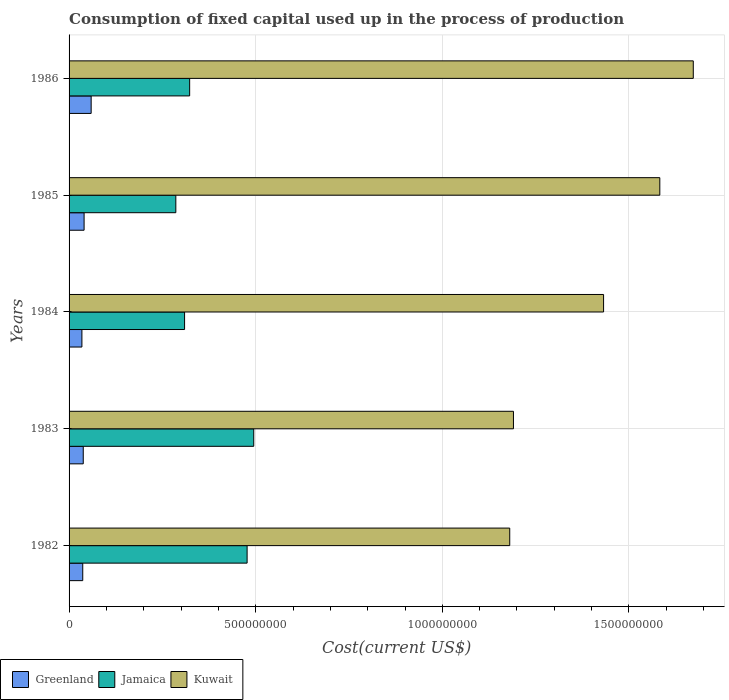Are the number of bars on each tick of the Y-axis equal?
Give a very brief answer. Yes. How many bars are there on the 3rd tick from the top?
Your response must be concise. 3. How many bars are there on the 1st tick from the bottom?
Ensure brevity in your answer.  3. What is the amount consumed in the process of production in Greenland in 1985?
Your response must be concise. 4.02e+07. Across all years, what is the maximum amount consumed in the process of production in Kuwait?
Offer a terse response. 1.67e+09. Across all years, what is the minimum amount consumed in the process of production in Jamaica?
Ensure brevity in your answer.  2.86e+08. In which year was the amount consumed in the process of production in Jamaica maximum?
Your answer should be compact. 1983. In which year was the amount consumed in the process of production in Jamaica minimum?
Keep it short and to the point. 1985. What is the total amount consumed in the process of production in Jamaica in the graph?
Your answer should be very brief. 1.89e+09. What is the difference between the amount consumed in the process of production in Kuwait in 1982 and that in 1985?
Ensure brevity in your answer.  -4.02e+08. What is the difference between the amount consumed in the process of production in Kuwait in 1983 and the amount consumed in the process of production in Jamaica in 1984?
Your response must be concise. 8.81e+08. What is the average amount consumed in the process of production in Greenland per year?
Make the answer very short. 4.17e+07. In the year 1983, what is the difference between the amount consumed in the process of production in Jamaica and amount consumed in the process of production in Greenland?
Give a very brief answer. 4.57e+08. What is the ratio of the amount consumed in the process of production in Greenland in 1984 to that in 1986?
Provide a short and direct response. 0.58. Is the amount consumed in the process of production in Jamaica in 1983 less than that in 1984?
Make the answer very short. No. Is the difference between the amount consumed in the process of production in Jamaica in 1985 and 1986 greater than the difference between the amount consumed in the process of production in Greenland in 1985 and 1986?
Give a very brief answer. No. What is the difference between the highest and the second highest amount consumed in the process of production in Kuwait?
Make the answer very short. 8.97e+07. What is the difference between the highest and the lowest amount consumed in the process of production in Jamaica?
Your answer should be compact. 2.09e+08. In how many years, is the amount consumed in the process of production in Greenland greater than the average amount consumed in the process of production in Greenland taken over all years?
Your answer should be compact. 1. What does the 3rd bar from the top in 1983 represents?
Provide a short and direct response. Greenland. What does the 1st bar from the bottom in 1986 represents?
Offer a very short reply. Greenland. What is the difference between two consecutive major ticks on the X-axis?
Your answer should be compact. 5.00e+08. Are the values on the major ticks of X-axis written in scientific E-notation?
Ensure brevity in your answer.  No. Where does the legend appear in the graph?
Offer a terse response. Bottom left. What is the title of the graph?
Your response must be concise. Consumption of fixed capital used up in the process of production. What is the label or title of the X-axis?
Make the answer very short. Cost(current US$). What is the Cost(current US$) of Greenland in 1982?
Make the answer very short. 3.66e+07. What is the Cost(current US$) in Jamaica in 1982?
Give a very brief answer. 4.77e+08. What is the Cost(current US$) of Kuwait in 1982?
Provide a short and direct response. 1.18e+09. What is the Cost(current US$) of Greenland in 1983?
Offer a very short reply. 3.80e+07. What is the Cost(current US$) in Jamaica in 1983?
Your answer should be compact. 4.95e+08. What is the Cost(current US$) of Kuwait in 1983?
Offer a very short reply. 1.19e+09. What is the Cost(current US$) in Greenland in 1984?
Provide a succinct answer. 3.44e+07. What is the Cost(current US$) in Jamaica in 1984?
Ensure brevity in your answer.  3.09e+08. What is the Cost(current US$) in Kuwait in 1984?
Keep it short and to the point. 1.43e+09. What is the Cost(current US$) in Greenland in 1985?
Provide a succinct answer. 4.02e+07. What is the Cost(current US$) of Jamaica in 1985?
Ensure brevity in your answer.  2.86e+08. What is the Cost(current US$) in Kuwait in 1985?
Provide a succinct answer. 1.58e+09. What is the Cost(current US$) of Greenland in 1986?
Make the answer very short. 5.92e+07. What is the Cost(current US$) in Jamaica in 1986?
Your answer should be very brief. 3.23e+08. What is the Cost(current US$) in Kuwait in 1986?
Keep it short and to the point. 1.67e+09. Across all years, what is the maximum Cost(current US$) in Greenland?
Offer a very short reply. 5.92e+07. Across all years, what is the maximum Cost(current US$) of Jamaica?
Provide a succinct answer. 4.95e+08. Across all years, what is the maximum Cost(current US$) in Kuwait?
Give a very brief answer. 1.67e+09. Across all years, what is the minimum Cost(current US$) of Greenland?
Make the answer very short. 3.44e+07. Across all years, what is the minimum Cost(current US$) of Jamaica?
Your answer should be compact. 2.86e+08. Across all years, what is the minimum Cost(current US$) of Kuwait?
Your response must be concise. 1.18e+09. What is the total Cost(current US$) in Greenland in the graph?
Your answer should be very brief. 2.08e+08. What is the total Cost(current US$) in Jamaica in the graph?
Your response must be concise. 1.89e+09. What is the total Cost(current US$) in Kuwait in the graph?
Your answer should be very brief. 7.06e+09. What is the difference between the Cost(current US$) in Greenland in 1982 and that in 1983?
Provide a short and direct response. -1.35e+06. What is the difference between the Cost(current US$) of Jamaica in 1982 and that in 1983?
Give a very brief answer. -1.78e+07. What is the difference between the Cost(current US$) in Kuwait in 1982 and that in 1983?
Your response must be concise. -9.98e+06. What is the difference between the Cost(current US$) of Greenland in 1982 and that in 1984?
Give a very brief answer. 2.26e+06. What is the difference between the Cost(current US$) in Jamaica in 1982 and that in 1984?
Your response must be concise. 1.68e+08. What is the difference between the Cost(current US$) of Kuwait in 1982 and that in 1984?
Give a very brief answer. -2.51e+08. What is the difference between the Cost(current US$) in Greenland in 1982 and that in 1985?
Make the answer very short. -3.58e+06. What is the difference between the Cost(current US$) in Jamaica in 1982 and that in 1985?
Offer a very short reply. 1.91e+08. What is the difference between the Cost(current US$) of Kuwait in 1982 and that in 1985?
Provide a short and direct response. -4.02e+08. What is the difference between the Cost(current US$) of Greenland in 1982 and that in 1986?
Provide a short and direct response. -2.25e+07. What is the difference between the Cost(current US$) of Jamaica in 1982 and that in 1986?
Give a very brief answer. 1.54e+08. What is the difference between the Cost(current US$) in Kuwait in 1982 and that in 1986?
Your answer should be very brief. -4.92e+08. What is the difference between the Cost(current US$) of Greenland in 1983 and that in 1984?
Your answer should be compact. 3.62e+06. What is the difference between the Cost(current US$) of Jamaica in 1983 and that in 1984?
Offer a terse response. 1.85e+08. What is the difference between the Cost(current US$) in Kuwait in 1983 and that in 1984?
Your answer should be very brief. -2.41e+08. What is the difference between the Cost(current US$) in Greenland in 1983 and that in 1985?
Offer a terse response. -2.23e+06. What is the difference between the Cost(current US$) of Jamaica in 1983 and that in 1985?
Provide a succinct answer. 2.09e+08. What is the difference between the Cost(current US$) in Kuwait in 1983 and that in 1985?
Offer a terse response. -3.92e+08. What is the difference between the Cost(current US$) in Greenland in 1983 and that in 1986?
Your answer should be very brief. -2.12e+07. What is the difference between the Cost(current US$) of Jamaica in 1983 and that in 1986?
Make the answer very short. 1.72e+08. What is the difference between the Cost(current US$) in Kuwait in 1983 and that in 1986?
Your answer should be very brief. -4.82e+08. What is the difference between the Cost(current US$) of Greenland in 1984 and that in 1985?
Your response must be concise. -5.85e+06. What is the difference between the Cost(current US$) of Jamaica in 1984 and that in 1985?
Give a very brief answer. 2.35e+07. What is the difference between the Cost(current US$) of Kuwait in 1984 and that in 1985?
Keep it short and to the point. -1.51e+08. What is the difference between the Cost(current US$) in Greenland in 1984 and that in 1986?
Your answer should be compact. -2.48e+07. What is the difference between the Cost(current US$) of Jamaica in 1984 and that in 1986?
Provide a succinct answer. -1.36e+07. What is the difference between the Cost(current US$) in Kuwait in 1984 and that in 1986?
Provide a succinct answer. -2.40e+08. What is the difference between the Cost(current US$) in Greenland in 1985 and that in 1986?
Give a very brief answer. -1.89e+07. What is the difference between the Cost(current US$) of Jamaica in 1985 and that in 1986?
Make the answer very short. -3.70e+07. What is the difference between the Cost(current US$) of Kuwait in 1985 and that in 1986?
Ensure brevity in your answer.  -8.97e+07. What is the difference between the Cost(current US$) of Greenland in 1982 and the Cost(current US$) of Jamaica in 1983?
Offer a very short reply. -4.58e+08. What is the difference between the Cost(current US$) of Greenland in 1982 and the Cost(current US$) of Kuwait in 1983?
Offer a very short reply. -1.15e+09. What is the difference between the Cost(current US$) of Jamaica in 1982 and the Cost(current US$) of Kuwait in 1983?
Your response must be concise. -7.14e+08. What is the difference between the Cost(current US$) of Greenland in 1982 and the Cost(current US$) of Jamaica in 1984?
Offer a terse response. -2.73e+08. What is the difference between the Cost(current US$) in Greenland in 1982 and the Cost(current US$) in Kuwait in 1984?
Provide a short and direct response. -1.40e+09. What is the difference between the Cost(current US$) in Jamaica in 1982 and the Cost(current US$) in Kuwait in 1984?
Your response must be concise. -9.55e+08. What is the difference between the Cost(current US$) in Greenland in 1982 and the Cost(current US$) in Jamaica in 1985?
Give a very brief answer. -2.49e+08. What is the difference between the Cost(current US$) in Greenland in 1982 and the Cost(current US$) in Kuwait in 1985?
Your response must be concise. -1.55e+09. What is the difference between the Cost(current US$) of Jamaica in 1982 and the Cost(current US$) of Kuwait in 1985?
Your answer should be compact. -1.11e+09. What is the difference between the Cost(current US$) of Greenland in 1982 and the Cost(current US$) of Jamaica in 1986?
Make the answer very short. -2.86e+08. What is the difference between the Cost(current US$) of Greenland in 1982 and the Cost(current US$) of Kuwait in 1986?
Ensure brevity in your answer.  -1.64e+09. What is the difference between the Cost(current US$) of Jamaica in 1982 and the Cost(current US$) of Kuwait in 1986?
Provide a short and direct response. -1.20e+09. What is the difference between the Cost(current US$) of Greenland in 1983 and the Cost(current US$) of Jamaica in 1984?
Make the answer very short. -2.71e+08. What is the difference between the Cost(current US$) in Greenland in 1983 and the Cost(current US$) in Kuwait in 1984?
Offer a very short reply. -1.39e+09. What is the difference between the Cost(current US$) of Jamaica in 1983 and the Cost(current US$) of Kuwait in 1984?
Give a very brief answer. -9.37e+08. What is the difference between the Cost(current US$) of Greenland in 1983 and the Cost(current US$) of Jamaica in 1985?
Your answer should be compact. -2.48e+08. What is the difference between the Cost(current US$) in Greenland in 1983 and the Cost(current US$) in Kuwait in 1985?
Your answer should be very brief. -1.54e+09. What is the difference between the Cost(current US$) in Jamaica in 1983 and the Cost(current US$) in Kuwait in 1985?
Your response must be concise. -1.09e+09. What is the difference between the Cost(current US$) in Greenland in 1983 and the Cost(current US$) in Jamaica in 1986?
Give a very brief answer. -2.85e+08. What is the difference between the Cost(current US$) of Greenland in 1983 and the Cost(current US$) of Kuwait in 1986?
Your answer should be very brief. -1.63e+09. What is the difference between the Cost(current US$) of Jamaica in 1983 and the Cost(current US$) of Kuwait in 1986?
Give a very brief answer. -1.18e+09. What is the difference between the Cost(current US$) of Greenland in 1984 and the Cost(current US$) of Jamaica in 1985?
Keep it short and to the point. -2.52e+08. What is the difference between the Cost(current US$) of Greenland in 1984 and the Cost(current US$) of Kuwait in 1985?
Your answer should be very brief. -1.55e+09. What is the difference between the Cost(current US$) in Jamaica in 1984 and the Cost(current US$) in Kuwait in 1985?
Your response must be concise. -1.27e+09. What is the difference between the Cost(current US$) of Greenland in 1984 and the Cost(current US$) of Jamaica in 1986?
Ensure brevity in your answer.  -2.89e+08. What is the difference between the Cost(current US$) in Greenland in 1984 and the Cost(current US$) in Kuwait in 1986?
Provide a succinct answer. -1.64e+09. What is the difference between the Cost(current US$) in Jamaica in 1984 and the Cost(current US$) in Kuwait in 1986?
Provide a short and direct response. -1.36e+09. What is the difference between the Cost(current US$) in Greenland in 1985 and the Cost(current US$) in Jamaica in 1986?
Your answer should be very brief. -2.83e+08. What is the difference between the Cost(current US$) of Greenland in 1985 and the Cost(current US$) of Kuwait in 1986?
Provide a short and direct response. -1.63e+09. What is the difference between the Cost(current US$) in Jamaica in 1985 and the Cost(current US$) in Kuwait in 1986?
Keep it short and to the point. -1.39e+09. What is the average Cost(current US$) in Greenland per year?
Provide a succinct answer. 4.17e+07. What is the average Cost(current US$) in Jamaica per year?
Provide a succinct answer. 3.78e+08. What is the average Cost(current US$) of Kuwait per year?
Offer a terse response. 1.41e+09. In the year 1982, what is the difference between the Cost(current US$) in Greenland and Cost(current US$) in Jamaica?
Provide a short and direct response. -4.40e+08. In the year 1982, what is the difference between the Cost(current US$) of Greenland and Cost(current US$) of Kuwait?
Provide a succinct answer. -1.14e+09. In the year 1982, what is the difference between the Cost(current US$) in Jamaica and Cost(current US$) in Kuwait?
Offer a terse response. -7.04e+08. In the year 1983, what is the difference between the Cost(current US$) of Greenland and Cost(current US$) of Jamaica?
Your answer should be compact. -4.57e+08. In the year 1983, what is the difference between the Cost(current US$) of Greenland and Cost(current US$) of Kuwait?
Offer a terse response. -1.15e+09. In the year 1983, what is the difference between the Cost(current US$) of Jamaica and Cost(current US$) of Kuwait?
Provide a short and direct response. -6.96e+08. In the year 1984, what is the difference between the Cost(current US$) in Greenland and Cost(current US$) in Jamaica?
Your answer should be very brief. -2.75e+08. In the year 1984, what is the difference between the Cost(current US$) of Greenland and Cost(current US$) of Kuwait?
Make the answer very short. -1.40e+09. In the year 1984, what is the difference between the Cost(current US$) of Jamaica and Cost(current US$) of Kuwait?
Give a very brief answer. -1.12e+09. In the year 1985, what is the difference between the Cost(current US$) in Greenland and Cost(current US$) in Jamaica?
Offer a terse response. -2.46e+08. In the year 1985, what is the difference between the Cost(current US$) of Greenland and Cost(current US$) of Kuwait?
Your answer should be very brief. -1.54e+09. In the year 1985, what is the difference between the Cost(current US$) in Jamaica and Cost(current US$) in Kuwait?
Provide a short and direct response. -1.30e+09. In the year 1986, what is the difference between the Cost(current US$) of Greenland and Cost(current US$) of Jamaica?
Provide a short and direct response. -2.64e+08. In the year 1986, what is the difference between the Cost(current US$) of Greenland and Cost(current US$) of Kuwait?
Provide a succinct answer. -1.61e+09. In the year 1986, what is the difference between the Cost(current US$) of Jamaica and Cost(current US$) of Kuwait?
Provide a short and direct response. -1.35e+09. What is the ratio of the Cost(current US$) in Greenland in 1982 to that in 1983?
Provide a succinct answer. 0.96. What is the ratio of the Cost(current US$) of Jamaica in 1982 to that in 1983?
Provide a succinct answer. 0.96. What is the ratio of the Cost(current US$) in Greenland in 1982 to that in 1984?
Keep it short and to the point. 1.07. What is the ratio of the Cost(current US$) in Jamaica in 1982 to that in 1984?
Offer a terse response. 1.54. What is the ratio of the Cost(current US$) in Kuwait in 1982 to that in 1984?
Offer a terse response. 0.82. What is the ratio of the Cost(current US$) in Greenland in 1982 to that in 1985?
Make the answer very short. 0.91. What is the ratio of the Cost(current US$) of Jamaica in 1982 to that in 1985?
Keep it short and to the point. 1.67. What is the ratio of the Cost(current US$) of Kuwait in 1982 to that in 1985?
Offer a terse response. 0.75. What is the ratio of the Cost(current US$) in Greenland in 1982 to that in 1986?
Ensure brevity in your answer.  0.62. What is the ratio of the Cost(current US$) in Jamaica in 1982 to that in 1986?
Provide a short and direct response. 1.48. What is the ratio of the Cost(current US$) of Kuwait in 1982 to that in 1986?
Provide a short and direct response. 0.71. What is the ratio of the Cost(current US$) in Greenland in 1983 to that in 1984?
Provide a short and direct response. 1.11. What is the ratio of the Cost(current US$) of Jamaica in 1983 to that in 1984?
Ensure brevity in your answer.  1.6. What is the ratio of the Cost(current US$) in Kuwait in 1983 to that in 1984?
Ensure brevity in your answer.  0.83. What is the ratio of the Cost(current US$) in Greenland in 1983 to that in 1985?
Provide a succinct answer. 0.94. What is the ratio of the Cost(current US$) of Jamaica in 1983 to that in 1985?
Provide a succinct answer. 1.73. What is the ratio of the Cost(current US$) of Kuwait in 1983 to that in 1985?
Provide a succinct answer. 0.75. What is the ratio of the Cost(current US$) in Greenland in 1983 to that in 1986?
Your answer should be compact. 0.64. What is the ratio of the Cost(current US$) of Jamaica in 1983 to that in 1986?
Offer a terse response. 1.53. What is the ratio of the Cost(current US$) of Kuwait in 1983 to that in 1986?
Your response must be concise. 0.71. What is the ratio of the Cost(current US$) in Greenland in 1984 to that in 1985?
Ensure brevity in your answer.  0.85. What is the ratio of the Cost(current US$) of Jamaica in 1984 to that in 1985?
Your answer should be very brief. 1.08. What is the ratio of the Cost(current US$) of Kuwait in 1984 to that in 1985?
Provide a succinct answer. 0.9. What is the ratio of the Cost(current US$) in Greenland in 1984 to that in 1986?
Ensure brevity in your answer.  0.58. What is the ratio of the Cost(current US$) in Jamaica in 1984 to that in 1986?
Keep it short and to the point. 0.96. What is the ratio of the Cost(current US$) in Kuwait in 1984 to that in 1986?
Provide a succinct answer. 0.86. What is the ratio of the Cost(current US$) of Greenland in 1985 to that in 1986?
Give a very brief answer. 0.68. What is the ratio of the Cost(current US$) in Jamaica in 1985 to that in 1986?
Provide a succinct answer. 0.89. What is the ratio of the Cost(current US$) in Kuwait in 1985 to that in 1986?
Give a very brief answer. 0.95. What is the difference between the highest and the second highest Cost(current US$) of Greenland?
Keep it short and to the point. 1.89e+07. What is the difference between the highest and the second highest Cost(current US$) of Jamaica?
Ensure brevity in your answer.  1.78e+07. What is the difference between the highest and the second highest Cost(current US$) of Kuwait?
Provide a short and direct response. 8.97e+07. What is the difference between the highest and the lowest Cost(current US$) in Greenland?
Your answer should be very brief. 2.48e+07. What is the difference between the highest and the lowest Cost(current US$) of Jamaica?
Offer a very short reply. 2.09e+08. What is the difference between the highest and the lowest Cost(current US$) of Kuwait?
Offer a very short reply. 4.92e+08. 